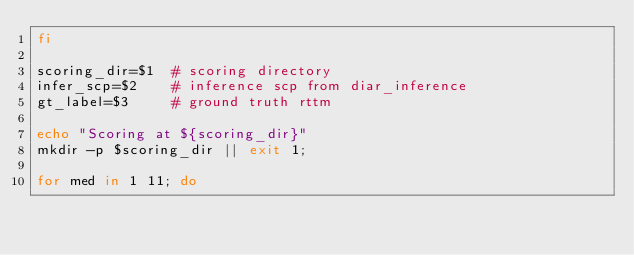Convert code to text. <code><loc_0><loc_0><loc_500><loc_500><_Bash_>fi

scoring_dir=$1  # scoring directory
infer_scp=$2    # inference scp from diar_inference
gt_label=$3     # ground truth rttm

echo "Scoring at ${scoring_dir}"
mkdir -p $scoring_dir || exit 1;

for med in 1 11; do</code> 